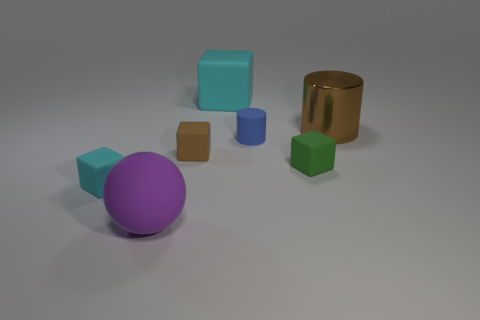The blue object that is the same material as the brown cube is what shape?
Offer a very short reply. Cylinder. Is there anything else that is the same color as the matte sphere?
Offer a very short reply. No. There is a big cylinder; is it the same color as the tiny cube behind the tiny green thing?
Make the answer very short. Yes. Is the number of brown metal cylinders in front of the tiny cyan cube less than the number of tiny green matte things?
Offer a very short reply. Yes. There is a cyan block in front of the large cyan matte object; what is it made of?
Give a very brief answer. Rubber. What number of other things are the same size as the purple ball?
Your response must be concise. 2. Do the blue cylinder and the matte thing in front of the small cyan thing have the same size?
Ensure brevity in your answer.  No. There is a big matte thing that is behind the tiny green matte cube in front of the blue matte thing left of the metallic cylinder; what is its shape?
Offer a terse response. Cube. Is the number of big cyan rubber objects less than the number of big purple metallic cylinders?
Give a very brief answer. No. There is a big brown cylinder; are there any big rubber balls on the right side of it?
Give a very brief answer. No. 